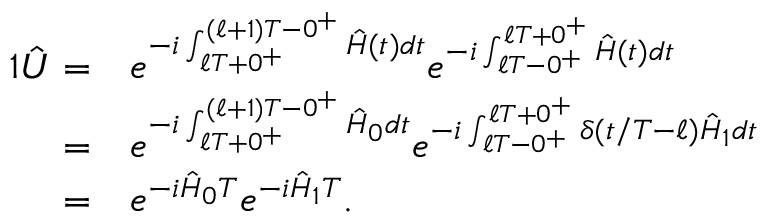Convert formula to latex. <formula><loc_0><loc_0><loc_500><loc_500>\begin{array} { r l } { { 1 } \hat { U } = } & { e ^ { - i \int _ { \ell T + 0 ^ { + } } ^ { ( \ell + 1 ) T - 0 ^ { + } } \hat { H } ( t ) d t } e ^ { - i \int _ { \ell T - 0 ^ { + } } ^ { \ell T + 0 ^ { + } } \hat { H } ( t ) d t } } \\ { = } & { e ^ { - i \int _ { \ell T + 0 ^ { + } } ^ { ( \ell + 1 ) T - 0 ^ { + } } \hat { H } _ { 0 } d t } e ^ { - i \int _ { \ell T - 0 ^ { + } } ^ { \ell T + 0 ^ { + } } \delta ( t / T - \ell ) \hat { H } _ { 1 } d t } } \\ { = } & { e ^ { - i \hat { H } _ { 0 } T } e ^ { - i \hat { H } _ { 1 } T } . } \end{array}</formula> 